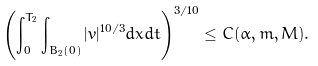<formula> <loc_0><loc_0><loc_500><loc_500>\left ( \int _ { 0 } ^ { T _ { 2 } } \int _ { B _ { 2 } ( 0 ) } | v | ^ { 1 0 / 3 } d x d t \right ) ^ { 3 / 1 0 } \leq C ( \alpha , m , M ) .</formula> 